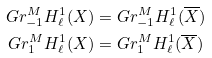Convert formula to latex. <formula><loc_0><loc_0><loc_500><loc_500>G r _ { - 1 } ^ { M } H ^ { 1 } _ { \ell } ( X ) & = G r _ { - 1 } ^ { M } H ^ { 1 } _ { \ell } ( \overline { X } ) \\ G r _ { 1 } ^ { M } H ^ { 1 } _ { \ell } ( X ) & = G r _ { 1 } ^ { M } H ^ { 1 } _ { \ell } ( \overline { X } )</formula> 